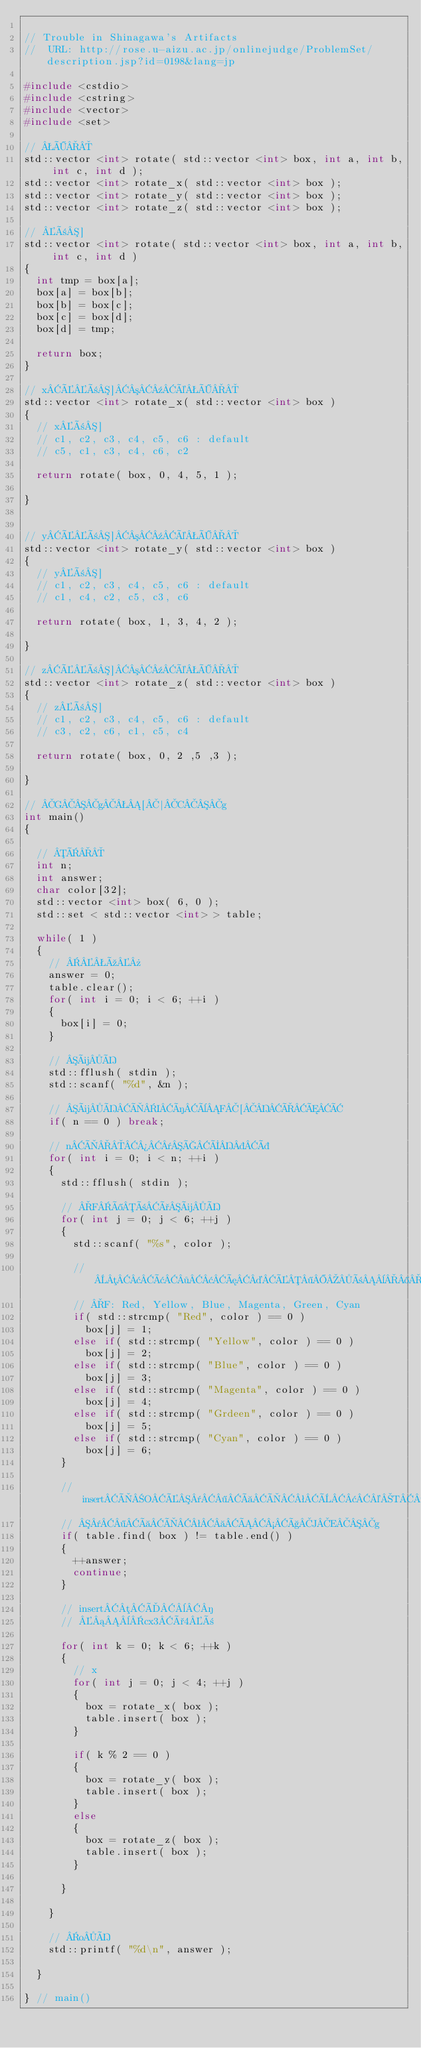<code> <loc_0><loc_0><loc_500><loc_500><_C++_>
// Trouble in Shinagawa's Artifacts
//  URL: http://rose.u-aizu.ac.jp/onlinejudge/ProblemSet/description.jsp?id=0198&lang=jp

#include <cstdio>
#include <cstring>
#include <vector>
#include <set>

// Ö
std::vector <int> rotate( std::vector <int> box, int a, int b, int c, int d );
std::vector <int> rotate_x( std::vector <int> box );
std::vector <int> rotate_y( std::vector <int> box );
std::vector <int> rotate_z( std::vector <int> box );

// ñ]
std::vector <int> rotate( std::vector <int> box, int a, int b, int c, int d )
{
	int tmp = box[a];
	box[a] = box[b];
	box[b] = box[c];
	box[c] = box[d];
	box[d] = tmp;

	return box;
}

// xÉñ]³¹éÖ
std::vector <int> rotate_x( std::vector <int> box )
{
	// xñ]
	// c1, c2, c3, c4, c5, c6 : default
	// c5, c1, c3, c4, c6, c2

	return rotate( box, 0, 4, 5, 1 );

}


// yÉñ]³¹éÖ
std::vector <int> rotate_y( std::vector <int> box )
{
	// yñ]
	// c1, c2, c3, c4, c5, c6 : default
	// c1, c4, c2, c5, c3, c6

	return rotate( box, 1, 3, 4, 2 );

}

// zÉñ]³¹éÖ
std::vector <int> rotate_z( std::vector <int> box )
{
	// zñ]
	// c1, c2, c3, c4, c5, c6 : default
	// c3, c2, c6, c1, c5, c4

	return rotate( box, 0, 2 ,5 ,3 );

}

// Gg[|Cg
int main()
{

	// Ï
	int n;
	int answer;
	char color[32];
	std::vector <int> box( 6, 0 );
	std::set < std::vector <int> > table;

	while( 1 )
	{
		// ú»
		answer = 0;
		table.clear();
		for( int i = 0; i < 6; ++i )
		{
			box[i] = 0;
		}

		// üÍ
		std::fflush( stdin );
		std::scanf( "%d", &n );

		// üÍÌIíèF[ÐÆÂ
		if( n == 0 ) break;

		// nÌ¾¯ÇÝÞ
		for( int i = 0; i < n; ++i )
		{
			std::fflush( stdin );

			// FîñðüÍ
			for( int j = 0; j < 6; ++j )
			{
				std::scanf( "%s", color );

				// µ¢â·¢æ¤É¶ñ¨®ÉÏ·
				// F: Red, Yellow, Blue, Magenta, Green, Cyan
				if( std::strcmp( "Red", color ) == 0 )
					box[j] = 1;
				else if( std::strcmp( "Yellow", color ) == 0 )
					box[j] = 2;
				else if( std::strcmp( "Blue", color ) == 0 )
					box[j] = 3;
				else if( std::strcmp( "Magenta", color ) == 0 )
					box[j] = 4;
				else if( std::strcmp( "Grdeen", color ) == 0 )
					box[j] = 5;
				else if( std::strcmp( "Cyan", color ) == 0 )
					box[j] = 6;
			}

			// insertÌOÉ¯¶àÌªÈ¢©T·
			// ¯¶àÌª Á½çJEg
			if( table.find( box ) != table.end() )
			{
				++answer;
				continue;
			}

			// insertµÄ¨­
			// ¡¨cx3ð4ñ

			for( int k = 0; k < 6; ++k )
			{
				// x
				for( int j = 0; j < 4; ++j )
				{
					box = rotate_x( box );
					table.insert( box );
				}

				if( k % 2 == 0 )
				{
					box = rotate_y( box );
					table.insert( box );
				}
				else
				{
					box = rotate_z( box );
					table.insert( box );
				}

			}

		}

		// oÍ
		std::printf( "%d\n", answer );

	}

} // main()</code> 